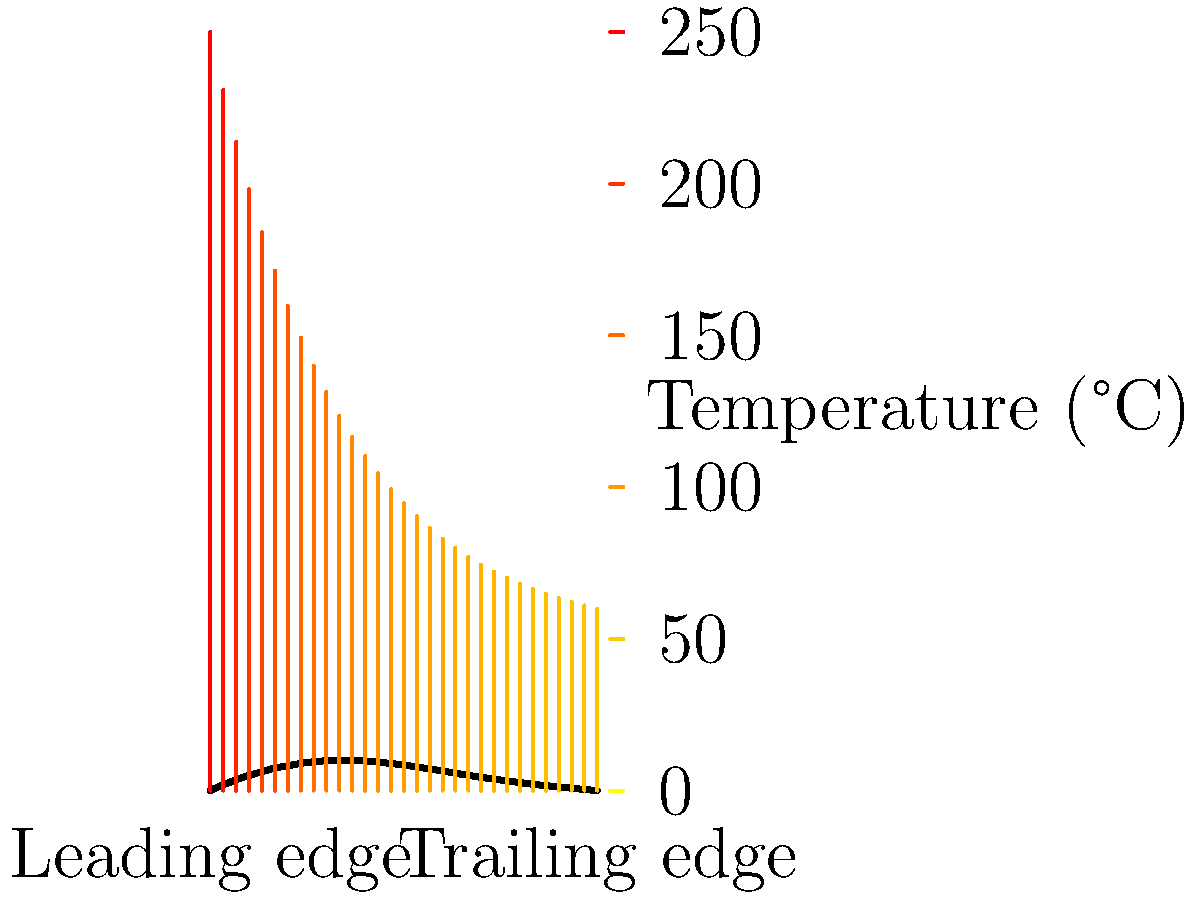The graph shows the heat distribution across a coated aircraft wing during supersonic flight. The x-axis represents the distance from the leading edge, and the color gradient indicates the temperature. Given that the coating's thermal conductivity is 15 W/(m·K) and its thickness is 2 mm, calculate the heat flux (in W/m²) at a point 25 cm from the leading edge, assuming a linear temperature gradient through the coating thickness. To calculate the heat flux, we'll follow these steps:

1) Identify the temperatures:
   - At x = 0 cm (leading edge): T₁ ≈ 250°C
   - At x = 25 cm: T₂ ≈ 175°C

2) Calculate the temperature difference (ΔT):
   ΔT = T₁ - T₂ = 250°C - 175°C = 75°C

3) Convert the coating thickness to meters:
   t = 2 mm = 0.002 m

4) Recall Fourier's Law of heat conduction:
   q = -k * (dT/dx)

   Where:
   q = heat flux (W/m²)
   k = thermal conductivity (W/(m·K))
   dT/dx = temperature gradient (K/m)

5) Calculate the temperature gradient through the coating:
   dT/dx = ΔT / t = 75°C / 0.002 m = 37,500 K/m

6) Apply Fourier's Law:
   q = -k * (dT/dx)
   q = -15 W/(m·K) * 37,500 K/m
   q = -562,500 W/m²

The negative sign indicates that heat flows from high to low temperature.
Answer: 562,500 W/m² 